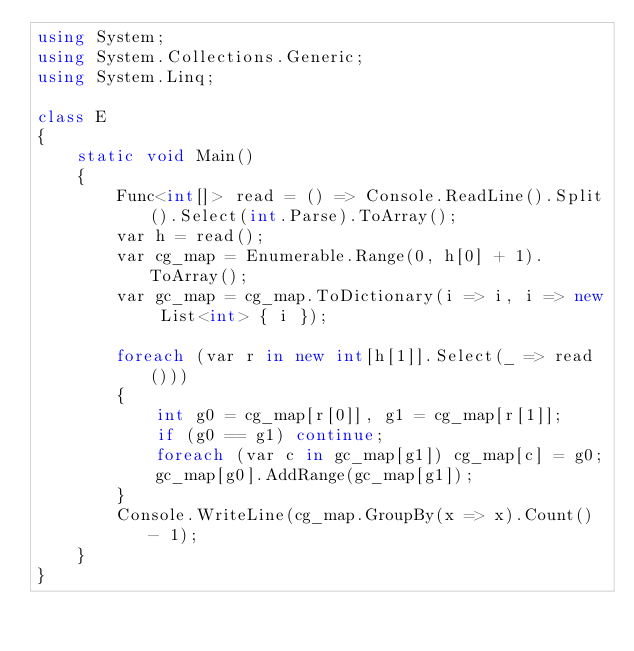Convert code to text. <code><loc_0><loc_0><loc_500><loc_500><_C#_>using System;
using System.Collections.Generic;
using System.Linq;

class E
{
	static void Main()
	{
		Func<int[]> read = () => Console.ReadLine().Split().Select(int.Parse).ToArray();
		var h = read();
		var cg_map = Enumerable.Range(0, h[0] + 1).ToArray();
		var gc_map = cg_map.ToDictionary(i => i, i => new List<int> { i });

		foreach (var r in new int[h[1]].Select(_ => read()))
		{
			int g0 = cg_map[r[0]], g1 = cg_map[r[1]];
			if (g0 == g1) continue;
			foreach (var c in gc_map[g1]) cg_map[c] = g0;
			gc_map[g0].AddRange(gc_map[g1]);
		}
		Console.WriteLine(cg_map.GroupBy(x => x).Count() - 1);
	}
}
</code> 